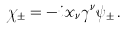<formula> <loc_0><loc_0><loc_500><loc_500>\chi _ { \pm } = - i x _ { \nu } \gamma ^ { \nu } \psi _ { \pm } \, .</formula> 